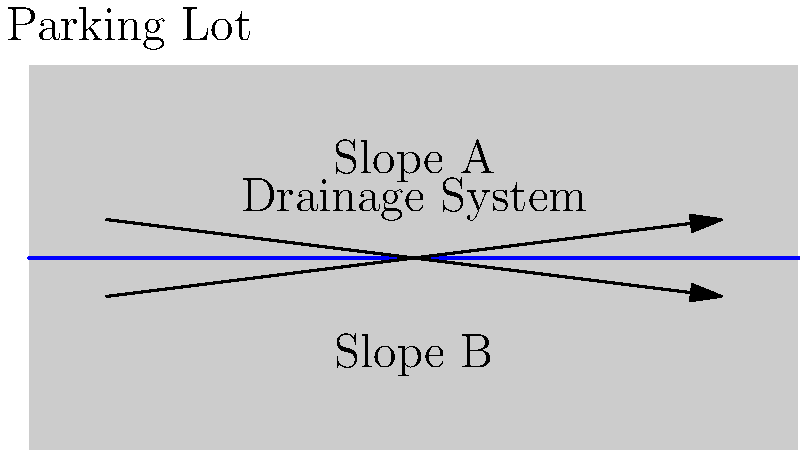As an auto repair shop owner specializing in electric and hybrid vehicles, you're planning to install a drainage system in your parking lot. The diagram shows two possible slopes for the drainage system. Which slope direction (A or B) would be more effective for water drainage, and what is the recommended minimum slope percentage for proper drainage in parking lots? To determine the optimal slope for a drainage system in a parking lot, we need to consider the following factors:

1. Direction of water flow: Water naturally flows downhill due to gravity.

2. Effectiveness of drainage: A proper slope ensures that water moves away from the parking area quickly, preventing pooling and potential damage to vehicles.

3. Industry standards: There are recommended minimum slopes for effective drainage in parking lots.

Step-by-step analysis:

1. Slope direction:
   - Slope A: Slopes downward from left to right
   - Slope B: Slopes downward from right to left

2. Effectiveness:
   Slope A is more effective because:
   - It allows water to flow naturally from the higher end (left) to the lower end (right)
   - This direction facilitates easier connection to existing stormwater systems, which are typically located at the perimeter of the property

3. Recommended minimum slope:
   - The industry standard for minimum slope in parking lots is typically 1-2%
   - This can be expressed as a ratio of 1:100 to 1:50 (vertical:horizontal)
   - A 1% slope means a 1-foot drop for every 100 feet of horizontal distance

4. Calculation example:
   For a 100-foot parking lot length:
   - Minimum drop: $100 \text{ ft} \times 1\% = 1 \text{ ft}$
   - Maximum drop: $100 \text{ ft} \times 2\% = 2 \text{ ft}$

Therefore, Slope A is more effective, and the recommended minimum slope percentage is 1-2%.
Answer: Slope A; 1-2% 